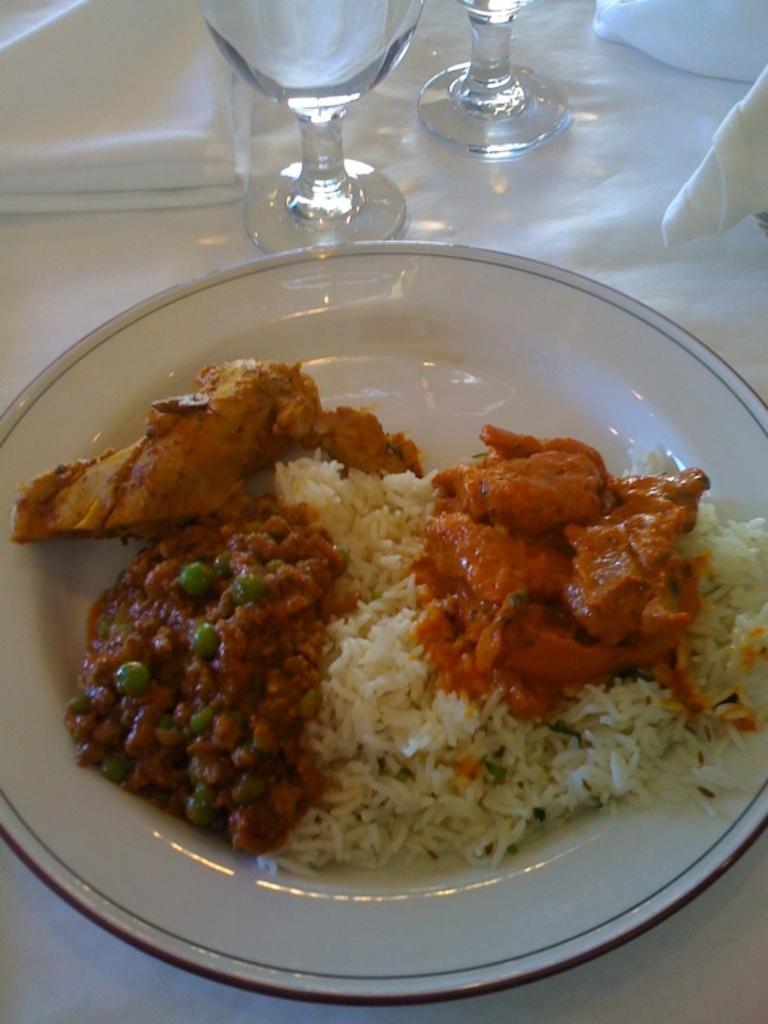Please provide a concise description of this image. In this picture there is a food on the plate. There is a plate and there are glasses and tissues on the table and the table is covered with white color cloth. 